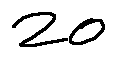Convert formula to latex. <formula><loc_0><loc_0><loc_500><loc_500>2 0</formula> 